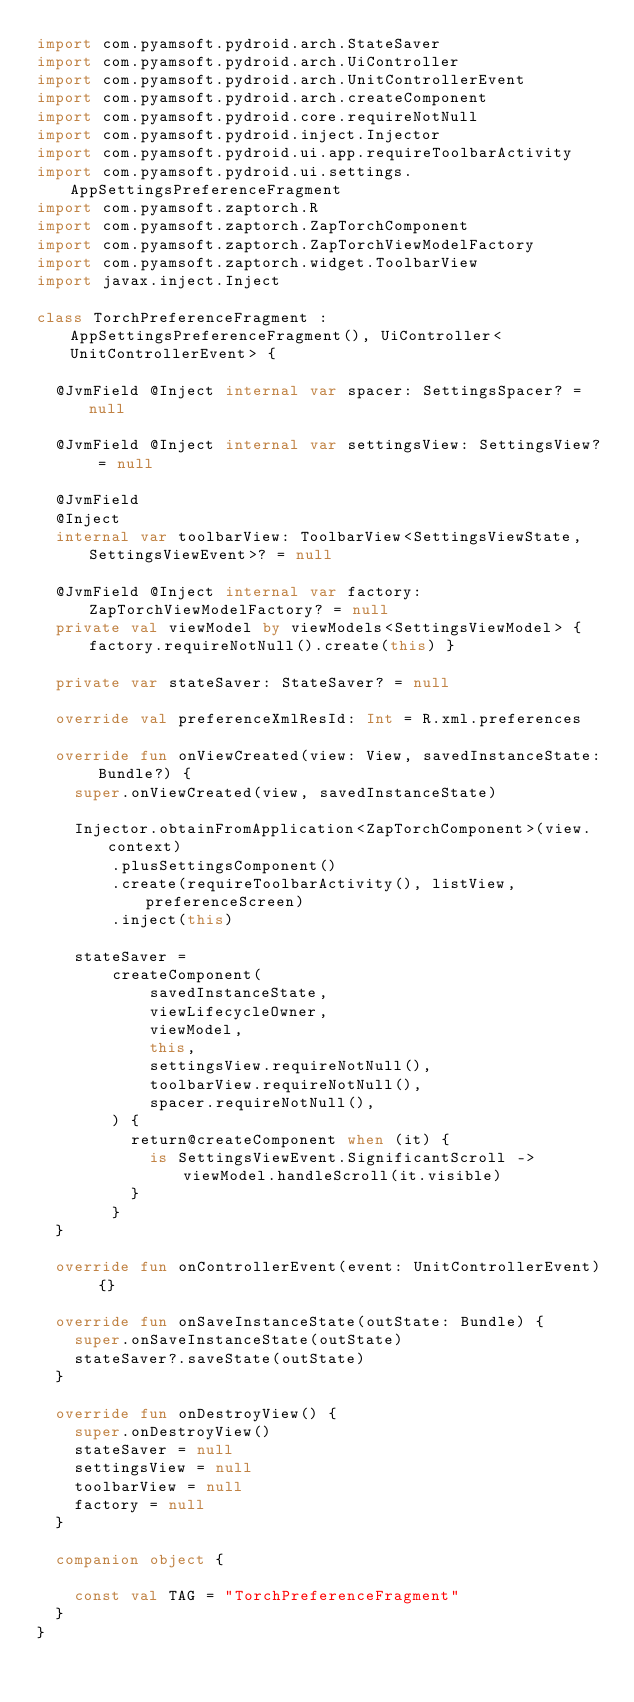<code> <loc_0><loc_0><loc_500><loc_500><_Kotlin_>import com.pyamsoft.pydroid.arch.StateSaver
import com.pyamsoft.pydroid.arch.UiController
import com.pyamsoft.pydroid.arch.UnitControllerEvent
import com.pyamsoft.pydroid.arch.createComponent
import com.pyamsoft.pydroid.core.requireNotNull
import com.pyamsoft.pydroid.inject.Injector
import com.pyamsoft.pydroid.ui.app.requireToolbarActivity
import com.pyamsoft.pydroid.ui.settings.AppSettingsPreferenceFragment
import com.pyamsoft.zaptorch.R
import com.pyamsoft.zaptorch.ZapTorchComponent
import com.pyamsoft.zaptorch.ZapTorchViewModelFactory
import com.pyamsoft.zaptorch.widget.ToolbarView
import javax.inject.Inject

class TorchPreferenceFragment : AppSettingsPreferenceFragment(), UiController<UnitControllerEvent> {

  @JvmField @Inject internal var spacer: SettingsSpacer? = null

  @JvmField @Inject internal var settingsView: SettingsView? = null

  @JvmField
  @Inject
  internal var toolbarView: ToolbarView<SettingsViewState, SettingsViewEvent>? = null

  @JvmField @Inject internal var factory: ZapTorchViewModelFactory? = null
  private val viewModel by viewModels<SettingsViewModel> { factory.requireNotNull().create(this) }

  private var stateSaver: StateSaver? = null

  override val preferenceXmlResId: Int = R.xml.preferences

  override fun onViewCreated(view: View, savedInstanceState: Bundle?) {
    super.onViewCreated(view, savedInstanceState)

    Injector.obtainFromApplication<ZapTorchComponent>(view.context)
        .plusSettingsComponent()
        .create(requireToolbarActivity(), listView, preferenceScreen)
        .inject(this)

    stateSaver =
        createComponent(
            savedInstanceState,
            viewLifecycleOwner,
            viewModel,
            this,
            settingsView.requireNotNull(),
            toolbarView.requireNotNull(),
            spacer.requireNotNull(),
        ) {
          return@createComponent when (it) {
            is SettingsViewEvent.SignificantScroll -> viewModel.handleScroll(it.visible)
          }
        }
  }

  override fun onControllerEvent(event: UnitControllerEvent) {}

  override fun onSaveInstanceState(outState: Bundle) {
    super.onSaveInstanceState(outState)
    stateSaver?.saveState(outState)
  }

  override fun onDestroyView() {
    super.onDestroyView()
    stateSaver = null
    settingsView = null
    toolbarView = null
    factory = null
  }

  companion object {

    const val TAG = "TorchPreferenceFragment"
  }
}
</code> 